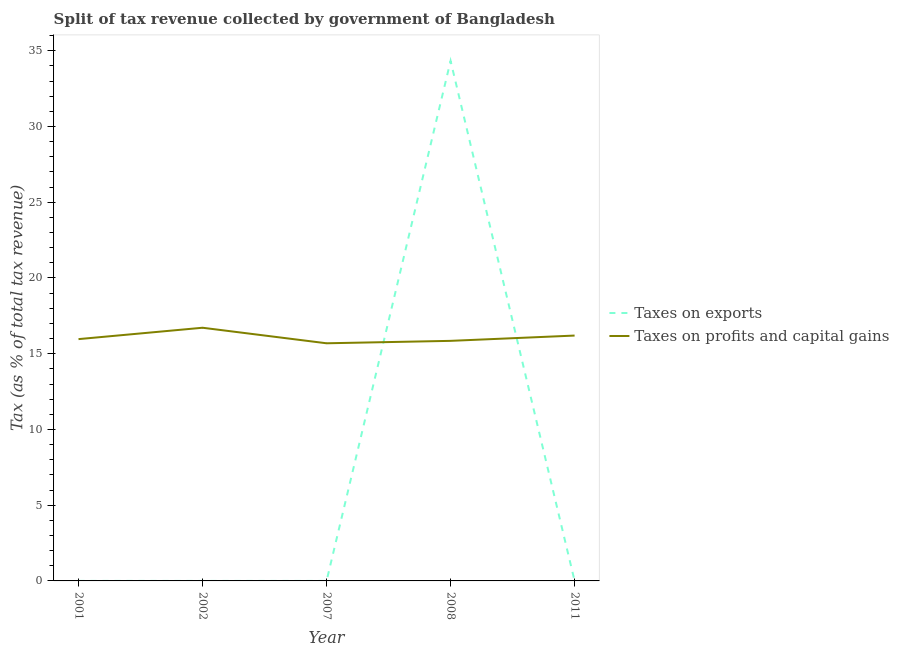How many different coloured lines are there?
Offer a terse response. 2. Is the number of lines equal to the number of legend labels?
Your answer should be compact. Yes. What is the percentage of revenue obtained from taxes on profits and capital gains in 2011?
Offer a terse response. 16.2. Across all years, what is the maximum percentage of revenue obtained from taxes on profits and capital gains?
Offer a very short reply. 16.72. Across all years, what is the minimum percentage of revenue obtained from taxes on exports?
Offer a very short reply. 1.00567926439932e-6. What is the total percentage of revenue obtained from taxes on exports in the graph?
Provide a succinct answer. 34.34. What is the difference between the percentage of revenue obtained from taxes on exports in 2001 and that in 2011?
Make the answer very short. 0. What is the difference between the percentage of revenue obtained from taxes on profits and capital gains in 2007 and the percentage of revenue obtained from taxes on exports in 2001?
Make the answer very short. 15.69. What is the average percentage of revenue obtained from taxes on profits and capital gains per year?
Your response must be concise. 16.08. In the year 2001, what is the difference between the percentage of revenue obtained from taxes on profits and capital gains and percentage of revenue obtained from taxes on exports?
Your response must be concise. 15.96. In how many years, is the percentage of revenue obtained from taxes on exports greater than 18 %?
Offer a terse response. 1. What is the ratio of the percentage of revenue obtained from taxes on exports in 2002 to that in 2008?
Keep it short and to the point. 1.384941313407419e-7. Is the percentage of revenue obtained from taxes on profits and capital gains in 2001 less than that in 2008?
Provide a short and direct response. No. Is the difference between the percentage of revenue obtained from taxes on profits and capital gains in 2001 and 2008 greater than the difference between the percentage of revenue obtained from taxes on exports in 2001 and 2008?
Make the answer very short. Yes. What is the difference between the highest and the second highest percentage of revenue obtained from taxes on profits and capital gains?
Give a very brief answer. 0.52. What is the difference between the highest and the lowest percentage of revenue obtained from taxes on profits and capital gains?
Provide a short and direct response. 1.03. In how many years, is the percentage of revenue obtained from taxes on exports greater than the average percentage of revenue obtained from taxes on exports taken over all years?
Your response must be concise. 1. Does the percentage of revenue obtained from taxes on exports monotonically increase over the years?
Keep it short and to the point. No. Is the percentage of revenue obtained from taxes on profits and capital gains strictly greater than the percentage of revenue obtained from taxes on exports over the years?
Offer a terse response. No. How many years are there in the graph?
Offer a very short reply. 5. Are the values on the major ticks of Y-axis written in scientific E-notation?
Your answer should be very brief. No. Where does the legend appear in the graph?
Ensure brevity in your answer.  Center right. How many legend labels are there?
Provide a short and direct response. 2. How are the legend labels stacked?
Your answer should be compact. Vertical. What is the title of the graph?
Your answer should be very brief. Split of tax revenue collected by government of Bangladesh. Does "Rural Population" appear as one of the legend labels in the graph?
Your response must be concise. No. What is the label or title of the Y-axis?
Provide a succinct answer. Tax (as % of total tax revenue). What is the Tax (as % of total tax revenue) in Taxes on exports in 2001?
Make the answer very short. 0. What is the Tax (as % of total tax revenue) in Taxes on profits and capital gains in 2001?
Ensure brevity in your answer.  15.96. What is the Tax (as % of total tax revenue) of Taxes on exports in 2002?
Make the answer very short. 4.755177544301731e-6. What is the Tax (as % of total tax revenue) of Taxes on profits and capital gains in 2002?
Offer a very short reply. 16.72. What is the Tax (as % of total tax revenue) in Taxes on exports in 2007?
Provide a short and direct response. 8.887465632262429e-5. What is the Tax (as % of total tax revenue) of Taxes on profits and capital gains in 2007?
Ensure brevity in your answer.  15.69. What is the Tax (as % of total tax revenue) in Taxes on exports in 2008?
Give a very brief answer. 34.33. What is the Tax (as % of total tax revenue) in Taxes on profits and capital gains in 2008?
Make the answer very short. 15.85. What is the Tax (as % of total tax revenue) in Taxes on exports in 2011?
Provide a short and direct response. 1.00567926439932e-6. What is the Tax (as % of total tax revenue) in Taxes on profits and capital gains in 2011?
Ensure brevity in your answer.  16.2. Across all years, what is the maximum Tax (as % of total tax revenue) in Taxes on exports?
Give a very brief answer. 34.33. Across all years, what is the maximum Tax (as % of total tax revenue) of Taxes on profits and capital gains?
Your response must be concise. 16.72. Across all years, what is the minimum Tax (as % of total tax revenue) in Taxes on exports?
Your response must be concise. 1.00567926439932e-6. Across all years, what is the minimum Tax (as % of total tax revenue) in Taxes on profits and capital gains?
Your answer should be compact. 15.69. What is the total Tax (as % of total tax revenue) in Taxes on exports in the graph?
Make the answer very short. 34.34. What is the total Tax (as % of total tax revenue) of Taxes on profits and capital gains in the graph?
Make the answer very short. 80.42. What is the difference between the Tax (as % of total tax revenue) of Taxes on exports in 2001 and that in 2002?
Give a very brief answer. 0. What is the difference between the Tax (as % of total tax revenue) of Taxes on profits and capital gains in 2001 and that in 2002?
Ensure brevity in your answer.  -0.75. What is the difference between the Tax (as % of total tax revenue) in Taxes on exports in 2001 and that in 2007?
Provide a short and direct response. 0. What is the difference between the Tax (as % of total tax revenue) in Taxes on profits and capital gains in 2001 and that in 2007?
Your answer should be compact. 0.28. What is the difference between the Tax (as % of total tax revenue) in Taxes on exports in 2001 and that in 2008?
Your answer should be very brief. -34.33. What is the difference between the Tax (as % of total tax revenue) in Taxes on profits and capital gains in 2001 and that in 2008?
Ensure brevity in your answer.  0.11. What is the difference between the Tax (as % of total tax revenue) of Taxes on exports in 2001 and that in 2011?
Ensure brevity in your answer.  0. What is the difference between the Tax (as % of total tax revenue) in Taxes on profits and capital gains in 2001 and that in 2011?
Offer a very short reply. -0.23. What is the difference between the Tax (as % of total tax revenue) in Taxes on exports in 2002 and that in 2007?
Your answer should be compact. -0. What is the difference between the Tax (as % of total tax revenue) of Taxes on profits and capital gains in 2002 and that in 2007?
Offer a very short reply. 1.03. What is the difference between the Tax (as % of total tax revenue) in Taxes on exports in 2002 and that in 2008?
Your answer should be compact. -34.33. What is the difference between the Tax (as % of total tax revenue) in Taxes on profits and capital gains in 2002 and that in 2008?
Make the answer very short. 0.87. What is the difference between the Tax (as % of total tax revenue) in Taxes on profits and capital gains in 2002 and that in 2011?
Keep it short and to the point. 0.52. What is the difference between the Tax (as % of total tax revenue) in Taxes on exports in 2007 and that in 2008?
Make the answer very short. -34.33. What is the difference between the Tax (as % of total tax revenue) in Taxes on profits and capital gains in 2007 and that in 2008?
Give a very brief answer. -0.16. What is the difference between the Tax (as % of total tax revenue) of Taxes on exports in 2007 and that in 2011?
Keep it short and to the point. 0. What is the difference between the Tax (as % of total tax revenue) in Taxes on profits and capital gains in 2007 and that in 2011?
Offer a terse response. -0.51. What is the difference between the Tax (as % of total tax revenue) of Taxes on exports in 2008 and that in 2011?
Offer a terse response. 34.33. What is the difference between the Tax (as % of total tax revenue) of Taxes on profits and capital gains in 2008 and that in 2011?
Your answer should be very brief. -0.35. What is the difference between the Tax (as % of total tax revenue) of Taxes on exports in 2001 and the Tax (as % of total tax revenue) of Taxes on profits and capital gains in 2002?
Provide a succinct answer. -16.71. What is the difference between the Tax (as % of total tax revenue) of Taxes on exports in 2001 and the Tax (as % of total tax revenue) of Taxes on profits and capital gains in 2007?
Provide a succinct answer. -15.69. What is the difference between the Tax (as % of total tax revenue) of Taxes on exports in 2001 and the Tax (as % of total tax revenue) of Taxes on profits and capital gains in 2008?
Offer a terse response. -15.85. What is the difference between the Tax (as % of total tax revenue) in Taxes on exports in 2001 and the Tax (as % of total tax revenue) in Taxes on profits and capital gains in 2011?
Provide a succinct answer. -16.2. What is the difference between the Tax (as % of total tax revenue) of Taxes on exports in 2002 and the Tax (as % of total tax revenue) of Taxes on profits and capital gains in 2007?
Provide a short and direct response. -15.69. What is the difference between the Tax (as % of total tax revenue) in Taxes on exports in 2002 and the Tax (as % of total tax revenue) in Taxes on profits and capital gains in 2008?
Make the answer very short. -15.85. What is the difference between the Tax (as % of total tax revenue) in Taxes on exports in 2002 and the Tax (as % of total tax revenue) in Taxes on profits and capital gains in 2011?
Your response must be concise. -16.2. What is the difference between the Tax (as % of total tax revenue) in Taxes on exports in 2007 and the Tax (as % of total tax revenue) in Taxes on profits and capital gains in 2008?
Your response must be concise. -15.85. What is the difference between the Tax (as % of total tax revenue) in Taxes on exports in 2007 and the Tax (as % of total tax revenue) in Taxes on profits and capital gains in 2011?
Offer a very short reply. -16.2. What is the difference between the Tax (as % of total tax revenue) of Taxes on exports in 2008 and the Tax (as % of total tax revenue) of Taxes on profits and capital gains in 2011?
Offer a terse response. 18.14. What is the average Tax (as % of total tax revenue) of Taxes on exports per year?
Give a very brief answer. 6.87. What is the average Tax (as % of total tax revenue) of Taxes on profits and capital gains per year?
Ensure brevity in your answer.  16.08. In the year 2001, what is the difference between the Tax (as % of total tax revenue) of Taxes on exports and Tax (as % of total tax revenue) of Taxes on profits and capital gains?
Make the answer very short. -15.96. In the year 2002, what is the difference between the Tax (as % of total tax revenue) of Taxes on exports and Tax (as % of total tax revenue) of Taxes on profits and capital gains?
Your answer should be compact. -16.72. In the year 2007, what is the difference between the Tax (as % of total tax revenue) of Taxes on exports and Tax (as % of total tax revenue) of Taxes on profits and capital gains?
Your answer should be very brief. -15.69. In the year 2008, what is the difference between the Tax (as % of total tax revenue) of Taxes on exports and Tax (as % of total tax revenue) of Taxes on profits and capital gains?
Give a very brief answer. 18.48. In the year 2011, what is the difference between the Tax (as % of total tax revenue) in Taxes on exports and Tax (as % of total tax revenue) in Taxes on profits and capital gains?
Your answer should be compact. -16.2. What is the ratio of the Tax (as % of total tax revenue) of Taxes on exports in 2001 to that in 2002?
Give a very brief answer. 274.05. What is the ratio of the Tax (as % of total tax revenue) in Taxes on profits and capital gains in 2001 to that in 2002?
Offer a terse response. 0.96. What is the ratio of the Tax (as % of total tax revenue) in Taxes on exports in 2001 to that in 2007?
Provide a succinct answer. 14.66. What is the ratio of the Tax (as % of total tax revenue) of Taxes on profits and capital gains in 2001 to that in 2007?
Your answer should be compact. 1.02. What is the ratio of the Tax (as % of total tax revenue) of Taxes on exports in 2001 to that in 2008?
Offer a very short reply. 0. What is the ratio of the Tax (as % of total tax revenue) in Taxes on profits and capital gains in 2001 to that in 2008?
Provide a short and direct response. 1.01. What is the ratio of the Tax (as % of total tax revenue) of Taxes on exports in 2001 to that in 2011?
Your response must be concise. 1295.81. What is the ratio of the Tax (as % of total tax revenue) in Taxes on profits and capital gains in 2001 to that in 2011?
Give a very brief answer. 0.99. What is the ratio of the Tax (as % of total tax revenue) in Taxes on exports in 2002 to that in 2007?
Provide a succinct answer. 0.05. What is the ratio of the Tax (as % of total tax revenue) in Taxes on profits and capital gains in 2002 to that in 2007?
Ensure brevity in your answer.  1.07. What is the ratio of the Tax (as % of total tax revenue) in Taxes on exports in 2002 to that in 2008?
Your answer should be compact. 0. What is the ratio of the Tax (as % of total tax revenue) in Taxes on profits and capital gains in 2002 to that in 2008?
Keep it short and to the point. 1.05. What is the ratio of the Tax (as % of total tax revenue) of Taxes on exports in 2002 to that in 2011?
Make the answer very short. 4.73. What is the ratio of the Tax (as % of total tax revenue) of Taxes on profits and capital gains in 2002 to that in 2011?
Provide a succinct answer. 1.03. What is the ratio of the Tax (as % of total tax revenue) in Taxes on exports in 2007 to that in 2011?
Ensure brevity in your answer.  88.37. What is the ratio of the Tax (as % of total tax revenue) in Taxes on profits and capital gains in 2007 to that in 2011?
Give a very brief answer. 0.97. What is the ratio of the Tax (as % of total tax revenue) in Taxes on exports in 2008 to that in 2011?
Make the answer very short. 3.41e+07. What is the ratio of the Tax (as % of total tax revenue) in Taxes on profits and capital gains in 2008 to that in 2011?
Provide a short and direct response. 0.98. What is the difference between the highest and the second highest Tax (as % of total tax revenue) of Taxes on exports?
Your response must be concise. 34.33. What is the difference between the highest and the second highest Tax (as % of total tax revenue) in Taxes on profits and capital gains?
Your answer should be compact. 0.52. What is the difference between the highest and the lowest Tax (as % of total tax revenue) of Taxes on exports?
Make the answer very short. 34.33. What is the difference between the highest and the lowest Tax (as % of total tax revenue) of Taxes on profits and capital gains?
Your answer should be compact. 1.03. 